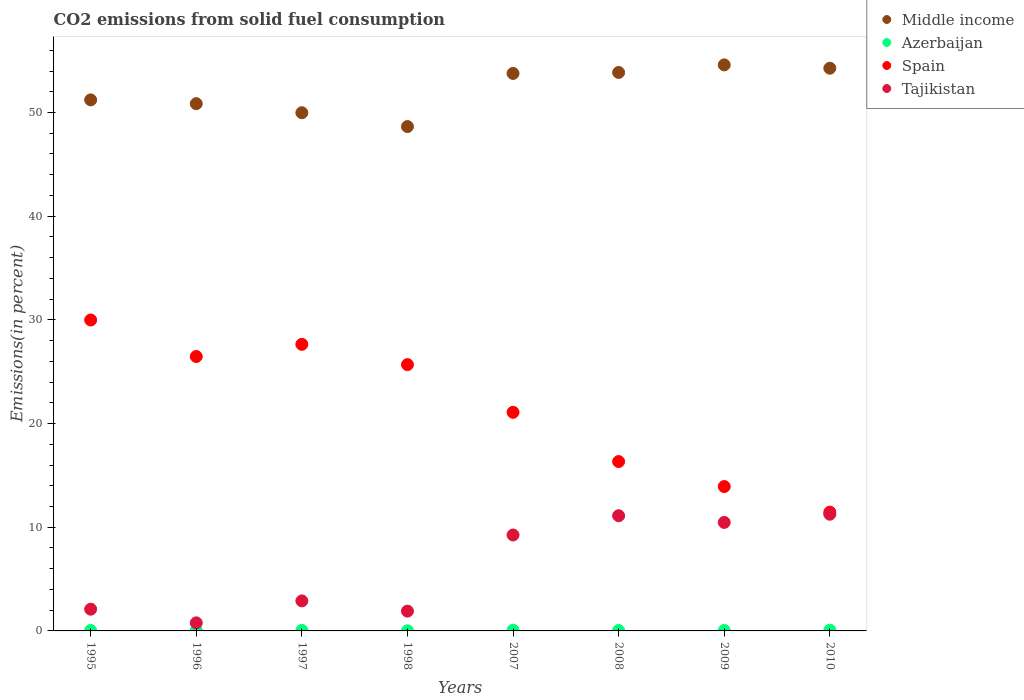How many different coloured dotlines are there?
Your answer should be very brief. 4. Is the number of dotlines equal to the number of legend labels?
Keep it short and to the point. Yes. What is the total CO2 emitted in Tajikistan in 1996?
Provide a short and direct response. 0.78. Across all years, what is the maximum total CO2 emitted in Tajikistan?
Offer a terse response. 11.25. Across all years, what is the minimum total CO2 emitted in Spain?
Offer a very short reply. 11.46. In which year was the total CO2 emitted in Middle income maximum?
Your answer should be very brief. 2009. In which year was the total CO2 emitted in Tajikistan minimum?
Keep it short and to the point. 1996. What is the total total CO2 emitted in Spain in the graph?
Offer a very short reply. 172.58. What is the difference between the total CO2 emitted in Spain in 1995 and that in 1998?
Offer a terse response. 4.3. What is the difference between the total CO2 emitted in Azerbaijan in 1997 and the total CO2 emitted in Tajikistan in 2010?
Your response must be concise. -11.21. What is the average total CO2 emitted in Spain per year?
Make the answer very short. 21.57. In the year 1996, what is the difference between the total CO2 emitted in Spain and total CO2 emitted in Middle income?
Your response must be concise. -24.39. In how many years, is the total CO2 emitted in Azerbaijan greater than 38 %?
Your answer should be compact. 0. What is the ratio of the total CO2 emitted in Azerbaijan in 1996 to that in 2008?
Provide a short and direct response. 1.13. Is the total CO2 emitted in Tajikistan in 1996 less than that in 1998?
Your answer should be very brief. Yes. What is the difference between the highest and the second highest total CO2 emitted in Tajikistan?
Offer a very short reply. 0.14. What is the difference between the highest and the lowest total CO2 emitted in Middle income?
Your response must be concise. 5.95. In how many years, is the total CO2 emitted in Azerbaijan greater than the average total CO2 emitted in Azerbaijan taken over all years?
Make the answer very short. 3. Is it the case that in every year, the sum of the total CO2 emitted in Azerbaijan and total CO2 emitted in Spain  is greater than the sum of total CO2 emitted in Tajikistan and total CO2 emitted in Middle income?
Give a very brief answer. No. Is it the case that in every year, the sum of the total CO2 emitted in Spain and total CO2 emitted in Azerbaijan  is greater than the total CO2 emitted in Tajikistan?
Offer a terse response. Yes. Is the total CO2 emitted in Azerbaijan strictly greater than the total CO2 emitted in Tajikistan over the years?
Give a very brief answer. No. Is the total CO2 emitted in Middle income strictly less than the total CO2 emitted in Spain over the years?
Your response must be concise. No. How many years are there in the graph?
Offer a terse response. 8. Are the values on the major ticks of Y-axis written in scientific E-notation?
Give a very brief answer. No. Does the graph contain any zero values?
Provide a short and direct response. No. How many legend labels are there?
Give a very brief answer. 4. What is the title of the graph?
Give a very brief answer. CO2 emissions from solid fuel consumption. Does "Oman" appear as one of the legend labels in the graph?
Give a very brief answer. No. What is the label or title of the Y-axis?
Your answer should be very brief. Emissions(in percent). What is the Emissions(in percent) in Middle income in 1995?
Ensure brevity in your answer.  51.22. What is the Emissions(in percent) of Azerbaijan in 1995?
Your answer should be very brief. 0.04. What is the Emissions(in percent) in Spain in 1995?
Offer a terse response. 29.99. What is the Emissions(in percent) in Tajikistan in 1995?
Offer a very short reply. 2.1. What is the Emissions(in percent) in Middle income in 1996?
Ensure brevity in your answer.  50.85. What is the Emissions(in percent) of Azerbaijan in 1996?
Your answer should be very brief. 0.05. What is the Emissions(in percent) in Spain in 1996?
Ensure brevity in your answer.  26.47. What is the Emissions(in percent) of Tajikistan in 1996?
Your response must be concise. 0.78. What is the Emissions(in percent) in Middle income in 1997?
Give a very brief answer. 49.98. What is the Emissions(in percent) in Azerbaijan in 1997?
Provide a short and direct response. 0.05. What is the Emissions(in percent) of Spain in 1997?
Your response must be concise. 27.64. What is the Emissions(in percent) of Tajikistan in 1997?
Offer a terse response. 2.9. What is the Emissions(in percent) in Middle income in 1998?
Provide a short and direct response. 48.64. What is the Emissions(in percent) in Azerbaijan in 1998?
Offer a very short reply. 0.01. What is the Emissions(in percent) in Spain in 1998?
Your response must be concise. 25.68. What is the Emissions(in percent) of Tajikistan in 1998?
Your answer should be compact. 1.91. What is the Emissions(in percent) in Middle income in 2007?
Your response must be concise. 53.77. What is the Emissions(in percent) of Azerbaijan in 2007?
Keep it short and to the point. 0.07. What is the Emissions(in percent) of Spain in 2007?
Offer a very short reply. 21.09. What is the Emissions(in percent) of Tajikistan in 2007?
Ensure brevity in your answer.  9.25. What is the Emissions(in percent) in Middle income in 2008?
Give a very brief answer. 53.86. What is the Emissions(in percent) in Azerbaijan in 2008?
Offer a very short reply. 0.04. What is the Emissions(in percent) of Spain in 2008?
Make the answer very short. 16.34. What is the Emissions(in percent) in Tajikistan in 2008?
Offer a terse response. 11.11. What is the Emissions(in percent) in Middle income in 2009?
Give a very brief answer. 54.6. What is the Emissions(in percent) in Azerbaijan in 2009?
Provide a succinct answer. 0.05. What is the Emissions(in percent) in Spain in 2009?
Keep it short and to the point. 13.92. What is the Emissions(in percent) in Tajikistan in 2009?
Provide a succinct answer. 10.47. What is the Emissions(in percent) of Middle income in 2010?
Provide a short and direct response. 54.27. What is the Emissions(in percent) of Azerbaijan in 2010?
Keep it short and to the point. 0.07. What is the Emissions(in percent) in Spain in 2010?
Your answer should be compact. 11.46. What is the Emissions(in percent) in Tajikistan in 2010?
Your answer should be compact. 11.25. Across all years, what is the maximum Emissions(in percent) of Middle income?
Offer a very short reply. 54.6. Across all years, what is the maximum Emissions(in percent) in Azerbaijan?
Keep it short and to the point. 0.07. Across all years, what is the maximum Emissions(in percent) in Spain?
Make the answer very short. 29.99. Across all years, what is the maximum Emissions(in percent) of Tajikistan?
Provide a short and direct response. 11.25. Across all years, what is the minimum Emissions(in percent) in Middle income?
Your response must be concise. 48.64. Across all years, what is the minimum Emissions(in percent) in Azerbaijan?
Give a very brief answer. 0.01. Across all years, what is the minimum Emissions(in percent) in Spain?
Offer a terse response. 11.46. Across all years, what is the minimum Emissions(in percent) of Tajikistan?
Your answer should be very brief. 0.78. What is the total Emissions(in percent) in Middle income in the graph?
Ensure brevity in your answer.  417.19. What is the total Emissions(in percent) in Azerbaijan in the graph?
Your answer should be compact. 0.38. What is the total Emissions(in percent) of Spain in the graph?
Your answer should be very brief. 172.58. What is the total Emissions(in percent) of Tajikistan in the graph?
Your response must be concise. 49.76. What is the difference between the Emissions(in percent) of Middle income in 1995 and that in 1996?
Make the answer very short. 0.36. What is the difference between the Emissions(in percent) of Azerbaijan in 1995 and that in 1996?
Ensure brevity in your answer.  -0. What is the difference between the Emissions(in percent) in Spain in 1995 and that in 1996?
Your response must be concise. 3.52. What is the difference between the Emissions(in percent) in Tajikistan in 1995 and that in 1996?
Your response must be concise. 1.32. What is the difference between the Emissions(in percent) of Middle income in 1995 and that in 1997?
Make the answer very short. 1.24. What is the difference between the Emissions(in percent) of Azerbaijan in 1995 and that in 1997?
Ensure brevity in your answer.  -0.01. What is the difference between the Emissions(in percent) of Spain in 1995 and that in 1997?
Offer a terse response. 2.35. What is the difference between the Emissions(in percent) in Tajikistan in 1995 and that in 1997?
Your answer should be very brief. -0.8. What is the difference between the Emissions(in percent) of Middle income in 1995 and that in 1998?
Your response must be concise. 2.57. What is the difference between the Emissions(in percent) of Azerbaijan in 1995 and that in 1998?
Offer a very short reply. 0.03. What is the difference between the Emissions(in percent) in Spain in 1995 and that in 1998?
Make the answer very short. 4.3. What is the difference between the Emissions(in percent) of Tajikistan in 1995 and that in 1998?
Give a very brief answer. 0.19. What is the difference between the Emissions(in percent) in Middle income in 1995 and that in 2007?
Provide a short and direct response. -2.55. What is the difference between the Emissions(in percent) in Azerbaijan in 1995 and that in 2007?
Offer a very short reply. -0.03. What is the difference between the Emissions(in percent) in Spain in 1995 and that in 2007?
Your response must be concise. 8.9. What is the difference between the Emissions(in percent) in Tajikistan in 1995 and that in 2007?
Keep it short and to the point. -7.16. What is the difference between the Emissions(in percent) in Middle income in 1995 and that in 2008?
Offer a very short reply. -2.65. What is the difference between the Emissions(in percent) of Azerbaijan in 1995 and that in 2008?
Provide a succinct answer. 0. What is the difference between the Emissions(in percent) in Spain in 1995 and that in 2008?
Your answer should be compact. 13.65. What is the difference between the Emissions(in percent) of Tajikistan in 1995 and that in 2008?
Ensure brevity in your answer.  -9.02. What is the difference between the Emissions(in percent) in Middle income in 1995 and that in 2009?
Ensure brevity in your answer.  -3.38. What is the difference between the Emissions(in percent) of Azerbaijan in 1995 and that in 2009?
Make the answer very short. -0. What is the difference between the Emissions(in percent) of Spain in 1995 and that in 2009?
Ensure brevity in your answer.  16.06. What is the difference between the Emissions(in percent) of Tajikistan in 1995 and that in 2009?
Keep it short and to the point. -8.37. What is the difference between the Emissions(in percent) of Middle income in 1995 and that in 2010?
Your answer should be compact. -3.05. What is the difference between the Emissions(in percent) in Azerbaijan in 1995 and that in 2010?
Provide a succinct answer. -0.03. What is the difference between the Emissions(in percent) of Spain in 1995 and that in 2010?
Make the answer very short. 18.53. What is the difference between the Emissions(in percent) of Tajikistan in 1995 and that in 2010?
Ensure brevity in your answer.  -9.16. What is the difference between the Emissions(in percent) in Middle income in 1996 and that in 1997?
Provide a succinct answer. 0.87. What is the difference between the Emissions(in percent) of Azerbaijan in 1996 and that in 1997?
Make the answer very short. -0. What is the difference between the Emissions(in percent) of Spain in 1996 and that in 1997?
Offer a very short reply. -1.17. What is the difference between the Emissions(in percent) in Tajikistan in 1996 and that in 1997?
Your response must be concise. -2.12. What is the difference between the Emissions(in percent) in Middle income in 1996 and that in 1998?
Make the answer very short. 2.21. What is the difference between the Emissions(in percent) of Azerbaijan in 1996 and that in 1998?
Your answer should be very brief. 0.04. What is the difference between the Emissions(in percent) in Spain in 1996 and that in 1998?
Provide a succinct answer. 0.78. What is the difference between the Emissions(in percent) of Tajikistan in 1996 and that in 1998?
Your response must be concise. -1.13. What is the difference between the Emissions(in percent) in Middle income in 1996 and that in 2007?
Offer a terse response. -2.92. What is the difference between the Emissions(in percent) of Azerbaijan in 1996 and that in 2007?
Your answer should be compact. -0.03. What is the difference between the Emissions(in percent) of Spain in 1996 and that in 2007?
Ensure brevity in your answer.  5.38. What is the difference between the Emissions(in percent) of Tajikistan in 1996 and that in 2007?
Provide a short and direct response. -8.47. What is the difference between the Emissions(in percent) of Middle income in 1996 and that in 2008?
Offer a very short reply. -3.01. What is the difference between the Emissions(in percent) in Azerbaijan in 1996 and that in 2008?
Provide a succinct answer. 0.01. What is the difference between the Emissions(in percent) of Spain in 1996 and that in 2008?
Give a very brief answer. 10.13. What is the difference between the Emissions(in percent) in Tajikistan in 1996 and that in 2008?
Your answer should be very brief. -10.33. What is the difference between the Emissions(in percent) of Middle income in 1996 and that in 2009?
Your response must be concise. -3.74. What is the difference between the Emissions(in percent) in Azerbaijan in 1996 and that in 2009?
Ensure brevity in your answer.  0. What is the difference between the Emissions(in percent) of Spain in 1996 and that in 2009?
Offer a very short reply. 12.54. What is the difference between the Emissions(in percent) of Tajikistan in 1996 and that in 2009?
Make the answer very short. -9.69. What is the difference between the Emissions(in percent) of Middle income in 1996 and that in 2010?
Keep it short and to the point. -3.42. What is the difference between the Emissions(in percent) of Azerbaijan in 1996 and that in 2010?
Your response must be concise. -0.03. What is the difference between the Emissions(in percent) in Spain in 1996 and that in 2010?
Your response must be concise. 15.01. What is the difference between the Emissions(in percent) of Tajikistan in 1996 and that in 2010?
Ensure brevity in your answer.  -10.48. What is the difference between the Emissions(in percent) of Middle income in 1997 and that in 1998?
Your answer should be very brief. 1.33. What is the difference between the Emissions(in percent) in Azerbaijan in 1997 and that in 1998?
Provide a short and direct response. 0.04. What is the difference between the Emissions(in percent) in Spain in 1997 and that in 1998?
Offer a very short reply. 1.96. What is the difference between the Emissions(in percent) in Tajikistan in 1997 and that in 1998?
Offer a terse response. 0.99. What is the difference between the Emissions(in percent) in Middle income in 1997 and that in 2007?
Provide a short and direct response. -3.79. What is the difference between the Emissions(in percent) of Azerbaijan in 1997 and that in 2007?
Your answer should be very brief. -0.02. What is the difference between the Emissions(in percent) of Spain in 1997 and that in 2007?
Ensure brevity in your answer.  6.56. What is the difference between the Emissions(in percent) in Tajikistan in 1997 and that in 2007?
Your answer should be very brief. -6.36. What is the difference between the Emissions(in percent) in Middle income in 1997 and that in 2008?
Provide a succinct answer. -3.88. What is the difference between the Emissions(in percent) of Azerbaijan in 1997 and that in 2008?
Your answer should be compact. 0.01. What is the difference between the Emissions(in percent) of Spain in 1997 and that in 2008?
Offer a very short reply. 11.31. What is the difference between the Emissions(in percent) in Tajikistan in 1997 and that in 2008?
Your answer should be compact. -8.21. What is the difference between the Emissions(in percent) of Middle income in 1997 and that in 2009?
Keep it short and to the point. -4.62. What is the difference between the Emissions(in percent) in Azerbaijan in 1997 and that in 2009?
Provide a short and direct response. 0. What is the difference between the Emissions(in percent) of Spain in 1997 and that in 2009?
Make the answer very short. 13.72. What is the difference between the Emissions(in percent) of Tajikistan in 1997 and that in 2009?
Your answer should be very brief. -7.57. What is the difference between the Emissions(in percent) of Middle income in 1997 and that in 2010?
Your answer should be compact. -4.29. What is the difference between the Emissions(in percent) of Azerbaijan in 1997 and that in 2010?
Provide a short and direct response. -0.02. What is the difference between the Emissions(in percent) of Spain in 1997 and that in 2010?
Your answer should be compact. 16.18. What is the difference between the Emissions(in percent) in Tajikistan in 1997 and that in 2010?
Provide a short and direct response. -8.36. What is the difference between the Emissions(in percent) in Middle income in 1998 and that in 2007?
Keep it short and to the point. -5.12. What is the difference between the Emissions(in percent) in Azerbaijan in 1998 and that in 2007?
Make the answer very short. -0.06. What is the difference between the Emissions(in percent) in Spain in 1998 and that in 2007?
Offer a terse response. 4.6. What is the difference between the Emissions(in percent) of Tajikistan in 1998 and that in 2007?
Your response must be concise. -7.34. What is the difference between the Emissions(in percent) in Middle income in 1998 and that in 2008?
Provide a succinct answer. -5.22. What is the difference between the Emissions(in percent) in Azerbaijan in 1998 and that in 2008?
Keep it short and to the point. -0.03. What is the difference between the Emissions(in percent) of Spain in 1998 and that in 2008?
Your response must be concise. 9.35. What is the difference between the Emissions(in percent) of Tajikistan in 1998 and that in 2008?
Give a very brief answer. -9.2. What is the difference between the Emissions(in percent) in Middle income in 1998 and that in 2009?
Ensure brevity in your answer.  -5.95. What is the difference between the Emissions(in percent) of Azerbaijan in 1998 and that in 2009?
Provide a succinct answer. -0.03. What is the difference between the Emissions(in percent) in Spain in 1998 and that in 2009?
Your answer should be very brief. 11.76. What is the difference between the Emissions(in percent) in Tajikistan in 1998 and that in 2009?
Keep it short and to the point. -8.56. What is the difference between the Emissions(in percent) in Middle income in 1998 and that in 2010?
Offer a very short reply. -5.63. What is the difference between the Emissions(in percent) in Azerbaijan in 1998 and that in 2010?
Offer a terse response. -0.06. What is the difference between the Emissions(in percent) of Spain in 1998 and that in 2010?
Give a very brief answer. 14.23. What is the difference between the Emissions(in percent) in Tajikistan in 1998 and that in 2010?
Keep it short and to the point. -9.35. What is the difference between the Emissions(in percent) in Middle income in 2007 and that in 2008?
Give a very brief answer. -0.09. What is the difference between the Emissions(in percent) of Azerbaijan in 2007 and that in 2008?
Your answer should be compact. 0.03. What is the difference between the Emissions(in percent) in Spain in 2007 and that in 2008?
Offer a terse response. 4.75. What is the difference between the Emissions(in percent) in Tajikistan in 2007 and that in 2008?
Offer a very short reply. -1.86. What is the difference between the Emissions(in percent) in Middle income in 2007 and that in 2009?
Offer a terse response. -0.83. What is the difference between the Emissions(in percent) of Azerbaijan in 2007 and that in 2009?
Make the answer very short. 0.03. What is the difference between the Emissions(in percent) in Spain in 2007 and that in 2009?
Make the answer very short. 7.16. What is the difference between the Emissions(in percent) of Tajikistan in 2007 and that in 2009?
Provide a short and direct response. -1.21. What is the difference between the Emissions(in percent) in Middle income in 2007 and that in 2010?
Provide a succinct answer. -0.5. What is the difference between the Emissions(in percent) of Spain in 2007 and that in 2010?
Offer a very short reply. 9.63. What is the difference between the Emissions(in percent) of Tajikistan in 2007 and that in 2010?
Provide a short and direct response. -2. What is the difference between the Emissions(in percent) in Middle income in 2008 and that in 2009?
Offer a terse response. -0.73. What is the difference between the Emissions(in percent) of Azerbaijan in 2008 and that in 2009?
Ensure brevity in your answer.  -0. What is the difference between the Emissions(in percent) in Spain in 2008 and that in 2009?
Provide a short and direct response. 2.41. What is the difference between the Emissions(in percent) in Tajikistan in 2008 and that in 2009?
Make the answer very short. 0.65. What is the difference between the Emissions(in percent) in Middle income in 2008 and that in 2010?
Keep it short and to the point. -0.41. What is the difference between the Emissions(in percent) in Azerbaijan in 2008 and that in 2010?
Give a very brief answer. -0.03. What is the difference between the Emissions(in percent) in Spain in 2008 and that in 2010?
Your answer should be very brief. 4.88. What is the difference between the Emissions(in percent) of Tajikistan in 2008 and that in 2010?
Ensure brevity in your answer.  -0.14. What is the difference between the Emissions(in percent) in Middle income in 2009 and that in 2010?
Make the answer very short. 0.32. What is the difference between the Emissions(in percent) of Azerbaijan in 2009 and that in 2010?
Ensure brevity in your answer.  -0.03. What is the difference between the Emissions(in percent) of Spain in 2009 and that in 2010?
Your response must be concise. 2.47. What is the difference between the Emissions(in percent) of Tajikistan in 2009 and that in 2010?
Provide a short and direct response. -0.79. What is the difference between the Emissions(in percent) in Middle income in 1995 and the Emissions(in percent) in Azerbaijan in 1996?
Make the answer very short. 51.17. What is the difference between the Emissions(in percent) of Middle income in 1995 and the Emissions(in percent) of Spain in 1996?
Your response must be concise. 24.75. What is the difference between the Emissions(in percent) in Middle income in 1995 and the Emissions(in percent) in Tajikistan in 1996?
Your answer should be compact. 50.44. What is the difference between the Emissions(in percent) in Azerbaijan in 1995 and the Emissions(in percent) in Spain in 1996?
Provide a short and direct response. -26.42. What is the difference between the Emissions(in percent) in Azerbaijan in 1995 and the Emissions(in percent) in Tajikistan in 1996?
Provide a short and direct response. -0.73. What is the difference between the Emissions(in percent) of Spain in 1995 and the Emissions(in percent) of Tajikistan in 1996?
Make the answer very short. 29.21. What is the difference between the Emissions(in percent) in Middle income in 1995 and the Emissions(in percent) in Azerbaijan in 1997?
Your answer should be compact. 51.17. What is the difference between the Emissions(in percent) in Middle income in 1995 and the Emissions(in percent) in Spain in 1997?
Give a very brief answer. 23.58. What is the difference between the Emissions(in percent) in Middle income in 1995 and the Emissions(in percent) in Tajikistan in 1997?
Your answer should be compact. 48.32. What is the difference between the Emissions(in percent) in Azerbaijan in 1995 and the Emissions(in percent) in Spain in 1997?
Make the answer very short. -27.6. What is the difference between the Emissions(in percent) of Azerbaijan in 1995 and the Emissions(in percent) of Tajikistan in 1997?
Provide a short and direct response. -2.85. What is the difference between the Emissions(in percent) of Spain in 1995 and the Emissions(in percent) of Tajikistan in 1997?
Your answer should be compact. 27.09. What is the difference between the Emissions(in percent) of Middle income in 1995 and the Emissions(in percent) of Azerbaijan in 1998?
Offer a terse response. 51.21. What is the difference between the Emissions(in percent) of Middle income in 1995 and the Emissions(in percent) of Spain in 1998?
Ensure brevity in your answer.  25.53. What is the difference between the Emissions(in percent) in Middle income in 1995 and the Emissions(in percent) in Tajikistan in 1998?
Ensure brevity in your answer.  49.31. What is the difference between the Emissions(in percent) in Azerbaijan in 1995 and the Emissions(in percent) in Spain in 1998?
Offer a very short reply. -25.64. What is the difference between the Emissions(in percent) of Azerbaijan in 1995 and the Emissions(in percent) of Tajikistan in 1998?
Your answer should be compact. -1.87. What is the difference between the Emissions(in percent) of Spain in 1995 and the Emissions(in percent) of Tajikistan in 1998?
Ensure brevity in your answer.  28.08. What is the difference between the Emissions(in percent) in Middle income in 1995 and the Emissions(in percent) in Azerbaijan in 2007?
Your response must be concise. 51.15. What is the difference between the Emissions(in percent) of Middle income in 1995 and the Emissions(in percent) of Spain in 2007?
Provide a short and direct response. 30.13. What is the difference between the Emissions(in percent) of Middle income in 1995 and the Emissions(in percent) of Tajikistan in 2007?
Your response must be concise. 41.96. What is the difference between the Emissions(in percent) in Azerbaijan in 1995 and the Emissions(in percent) in Spain in 2007?
Your answer should be very brief. -21.04. What is the difference between the Emissions(in percent) in Azerbaijan in 1995 and the Emissions(in percent) in Tajikistan in 2007?
Your response must be concise. -9.21. What is the difference between the Emissions(in percent) of Spain in 1995 and the Emissions(in percent) of Tajikistan in 2007?
Provide a short and direct response. 20.74. What is the difference between the Emissions(in percent) in Middle income in 1995 and the Emissions(in percent) in Azerbaijan in 2008?
Offer a terse response. 51.18. What is the difference between the Emissions(in percent) in Middle income in 1995 and the Emissions(in percent) in Spain in 2008?
Offer a terse response. 34.88. What is the difference between the Emissions(in percent) of Middle income in 1995 and the Emissions(in percent) of Tajikistan in 2008?
Make the answer very short. 40.11. What is the difference between the Emissions(in percent) of Azerbaijan in 1995 and the Emissions(in percent) of Spain in 2008?
Give a very brief answer. -16.29. What is the difference between the Emissions(in percent) in Azerbaijan in 1995 and the Emissions(in percent) in Tajikistan in 2008?
Make the answer very short. -11.07. What is the difference between the Emissions(in percent) in Spain in 1995 and the Emissions(in percent) in Tajikistan in 2008?
Ensure brevity in your answer.  18.88. What is the difference between the Emissions(in percent) of Middle income in 1995 and the Emissions(in percent) of Azerbaijan in 2009?
Ensure brevity in your answer.  51.17. What is the difference between the Emissions(in percent) in Middle income in 1995 and the Emissions(in percent) in Spain in 2009?
Provide a succinct answer. 37.29. What is the difference between the Emissions(in percent) in Middle income in 1995 and the Emissions(in percent) in Tajikistan in 2009?
Your answer should be very brief. 40.75. What is the difference between the Emissions(in percent) of Azerbaijan in 1995 and the Emissions(in percent) of Spain in 2009?
Provide a succinct answer. -13.88. What is the difference between the Emissions(in percent) in Azerbaijan in 1995 and the Emissions(in percent) in Tajikistan in 2009?
Provide a succinct answer. -10.42. What is the difference between the Emissions(in percent) of Spain in 1995 and the Emissions(in percent) of Tajikistan in 2009?
Your answer should be compact. 19.52. What is the difference between the Emissions(in percent) in Middle income in 1995 and the Emissions(in percent) in Azerbaijan in 2010?
Offer a very short reply. 51.15. What is the difference between the Emissions(in percent) of Middle income in 1995 and the Emissions(in percent) of Spain in 2010?
Your response must be concise. 39.76. What is the difference between the Emissions(in percent) of Middle income in 1995 and the Emissions(in percent) of Tajikistan in 2010?
Offer a very short reply. 39.96. What is the difference between the Emissions(in percent) in Azerbaijan in 1995 and the Emissions(in percent) in Spain in 2010?
Offer a very short reply. -11.41. What is the difference between the Emissions(in percent) in Azerbaijan in 1995 and the Emissions(in percent) in Tajikistan in 2010?
Make the answer very short. -11.21. What is the difference between the Emissions(in percent) of Spain in 1995 and the Emissions(in percent) of Tajikistan in 2010?
Your response must be concise. 18.73. What is the difference between the Emissions(in percent) of Middle income in 1996 and the Emissions(in percent) of Azerbaijan in 1997?
Make the answer very short. 50.8. What is the difference between the Emissions(in percent) of Middle income in 1996 and the Emissions(in percent) of Spain in 1997?
Provide a short and direct response. 23.21. What is the difference between the Emissions(in percent) of Middle income in 1996 and the Emissions(in percent) of Tajikistan in 1997?
Offer a very short reply. 47.96. What is the difference between the Emissions(in percent) of Azerbaijan in 1996 and the Emissions(in percent) of Spain in 1997?
Your response must be concise. -27.59. What is the difference between the Emissions(in percent) of Azerbaijan in 1996 and the Emissions(in percent) of Tajikistan in 1997?
Offer a terse response. -2.85. What is the difference between the Emissions(in percent) in Spain in 1996 and the Emissions(in percent) in Tajikistan in 1997?
Provide a short and direct response. 23.57. What is the difference between the Emissions(in percent) in Middle income in 1996 and the Emissions(in percent) in Azerbaijan in 1998?
Offer a very short reply. 50.84. What is the difference between the Emissions(in percent) of Middle income in 1996 and the Emissions(in percent) of Spain in 1998?
Ensure brevity in your answer.  25.17. What is the difference between the Emissions(in percent) in Middle income in 1996 and the Emissions(in percent) in Tajikistan in 1998?
Keep it short and to the point. 48.94. What is the difference between the Emissions(in percent) of Azerbaijan in 1996 and the Emissions(in percent) of Spain in 1998?
Offer a very short reply. -25.64. What is the difference between the Emissions(in percent) of Azerbaijan in 1996 and the Emissions(in percent) of Tajikistan in 1998?
Offer a very short reply. -1.86. What is the difference between the Emissions(in percent) of Spain in 1996 and the Emissions(in percent) of Tajikistan in 1998?
Your answer should be very brief. 24.56. What is the difference between the Emissions(in percent) in Middle income in 1996 and the Emissions(in percent) in Azerbaijan in 2007?
Give a very brief answer. 50.78. What is the difference between the Emissions(in percent) in Middle income in 1996 and the Emissions(in percent) in Spain in 2007?
Keep it short and to the point. 29.77. What is the difference between the Emissions(in percent) in Middle income in 1996 and the Emissions(in percent) in Tajikistan in 2007?
Offer a terse response. 41.6. What is the difference between the Emissions(in percent) in Azerbaijan in 1996 and the Emissions(in percent) in Spain in 2007?
Provide a succinct answer. -21.04. What is the difference between the Emissions(in percent) of Azerbaijan in 1996 and the Emissions(in percent) of Tajikistan in 2007?
Provide a short and direct response. -9.21. What is the difference between the Emissions(in percent) of Spain in 1996 and the Emissions(in percent) of Tajikistan in 2007?
Provide a short and direct response. 17.21. What is the difference between the Emissions(in percent) in Middle income in 1996 and the Emissions(in percent) in Azerbaijan in 2008?
Keep it short and to the point. 50.81. What is the difference between the Emissions(in percent) of Middle income in 1996 and the Emissions(in percent) of Spain in 2008?
Ensure brevity in your answer.  34.52. What is the difference between the Emissions(in percent) in Middle income in 1996 and the Emissions(in percent) in Tajikistan in 2008?
Your response must be concise. 39.74. What is the difference between the Emissions(in percent) of Azerbaijan in 1996 and the Emissions(in percent) of Spain in 2008?
Provide a short and direct response. -16.29. What is the difference between the Emissions(in percent) of Azerbaijan in 1996 and the Emissions(in percent) of Tajikistan in 2008?
Offer a terse response. -11.06. What is the difference between the Emissions(in percent) in Spain in 1996 and the Emissions(in percent) in Tajikistan in 2008?
Your answer should be compact. 15.36. What is the difference between the Emissions(in percent) of Middle income in 1996 and the Emissions(in percent) of Azerbaijan in 2009?
Your answer should be very brief. 50.81. What is the difference between the Emissions(in percent) of Middle income in 1996 and the Emissions(in percent) of Spain in 2009?
Offer a very short reply. 36.93. What is the difference between the Emissions(in percent) in Middle income in 1996 and the Emissions(in percent) in Tajikistan in 2009?
Offer a very short reply. 40.39. What is the difference between the Emissions(in percent) in Azerbaijan in 1996 and the Emissions(in percent) in Spain in 2009?
Offer a terse response. -13.88. What is the difference between the Emissions(in percent) of Azerbaijan in 1996 and the Emissions(in percent) of Tajikistan in 2009?
Your response must be concise. -10.42. What is the difference between the Emissions(in percent) of Spain in 1996 and the Emissions(in percent) of Tajikistan in 2009?
Keep it short and to the point. 16. What is the difference between the Emissions(in percent) of Middle income in 1996 and the Emissions(in percent) of Azerbaijan in 2010?
Keep it short and to the point. 50.78. What is the difference between the Emissions(in percent) in Middle income in 1996 and the Emissions(in percent) in Spain in 2010?
Your answer should be very brief. 39.4. What is the difference between the Emissions(in percent) in Middle income in 1996 and the Emissions(in percent) in Tajikistan in 2010?
Offer a very short reply. 39.6. What is the difference between the Emissions(in percent) of Azerbaijan in 1996 and the Emissions(in percent) of Spain in 2010?
Provide a succinct answer. -11.41. What is the difference between the Emissions(in percent) of Azerbaijan in 1996 and the Emissions(in percent) of Tajikistan in 2010?
Your response must be concise. -11.21. What is the difference between the Emissions(in percent) in Spain in 1996 and the Emissions(in percent) in Tajikistan in 2010?
Give a very brief answer. 15.21. What is the difference between the Emissions(in percent) in Middle income in 1997 and the Emissions(in percent) in Azerbaijan in 1998?
Your response must be concise. 49.97. What is the difference between the Emissions(in percent) in Middle income in 1997 and the Emissions(in percent) in Spain in 1998?
Your answer should be very brief. 24.29. What is the difference between the Emissions(in percent) in Middle income in 1997 and the Emissions(in percent) in Tajikistan in 1998?
Offer a very short reply. 48.07. What is the difference between the Emissions(in percent) of Azerbaijan in 1997 and the Emissions(in percent) of Spain in 1998?
Your answer should be compact. -25.64. What is the difference between the Emissions(in percent) of Azerbaijan in 1997 and the Emissions(in percent) of Tajikistan in 1998?
Keep it short and to the point. -1.86. What is the difference between the Emissions(in percent) in Spain in 1997 and the Emissions(in percent) in Tajikistan in 1998?
Your answer should be compact. 25.73. What is the difference between the Emissions(in percent) of Middle income in 1997 and the Emissions(in percent) of Azerbaijan in 2007?
Offer a very short reply. 49.91. What is the difference between the Emissions(in percent) in Middle income in 1997 and the Emissions(in percent) in Spain in 2007?
Provide a short and direct response. 28.89. What is the difference between the Emissions(in percent) in Middle income in 1997 and the Emissions(in percent) in Tajikistan in 2007?
Your answer should be compact. 40.73. What is the difference between the Emissions(in percent) of Azerbaijan in 1997 and the Emissions(in percent) of Spain in 2007?
Give a very brief answer. -21.04. What is the difference between the Emissions(in percent) of Azerbaijan in 1997 and the Emissions(in percent) of Tajikistan in 2007?
Make the answer very short. -9.2. What is the difference between the Emissions(in percent) in Spain in 1997 and the Emissions(in percent) in Tajikistan in 2007?
Your answer should be compact. 18.39. What is the difference between the Emissions(in percent) in Middle income in 1997 and the Emissions(in percent) in Azerbaijan in 2008?
Offer a very short reply. 49.94. What is the difference between the Emissions(in percent) of Middle income in 1997 and the Emissions(in percent) of Spain in 2008?
Keep it short and to the point. 33.64. What is the difference between the Emissions(in percent) of Middle income in 1997 and the Emissions(in percent) of Tajikistan in 2008?
Provide a short and direct response. 38.87. What is the difference between the Emissions(in percent) of Azerbaijan in 1997 and the Emissions(in percent) of Spain in 2008?
Offer a terse response. -16.29. What is the difference between the Emissions(in percent) of Azerbaijan in 1997 and the Emissions(in percent) of Tajikistan in 2008?
Your answer should be very brief. -11.06. What is the difference between the Emissions(in percent) of Spain in 1997 and the Emissions(in percent) of Tajikistan in 2008?
Your answer should be compact. 16.53. What is the difference between the Emissions(in percent) in Middle income in 1997 and the Emissions(in percent) in Azerbaijan in 2009?
Your answer should be very brief. 49.93. What is the difference between the Emissions(in percent) in Middle income in 1997 and the Emissions(in percent) in Spain in 2009?
Give a very brief answer. 36.05. What is the difference between the Emissions(in percent) in Middle income in 1997 and the Emissions(in percent) in Tajikistan in 2009?
Your response must be concise. 39.51. What is the difference between the Emissions(in percent) in Azerbaijan in 1997 and the Emissions(in percent) in Spain in 2009?
Provide a succinct answer. -13.88. What is the difference between the Emissions(in percent) in Azerbaijan in 1997 and the Emissions(in percent) in Tajikistan in 2009?
Provide a succinct answer. -10.42. What is the difference between the Emissions(in percent) in Spain in 1997 and the Emissions(in percent) in Tajikistan in 2009?
Make the answer very short. 17.18. What is the difference between the Emissions(in percent) of Middle income in 1997 and the Emissions(in percent) of Azerbaijan in 2010?
Provide a succinct answer. 49.91. What is the difference between the Emissions(in percent) of Middle income in 1997 and the Emissions(in percent) of Spain in 2010?
Your answer should be very brief. 38.52. What is the difference between the Emissions(in percent) of Middle income in 1997 and the Emissions(in percent) of Tajikistan in 2010?
Keep it short and to the point. 38.72. What is the difference between the Emissions(in percent) of Azerbaijan in 1997 and the Emissions(in percent) of Spain in 2010?
Provide a succinct answer. -11.41. What is the difference between the Emissions(in percent) in Azerbaijan in 1997 and the Emissions(in percent) in Tajikistan in 2010?
Offer a terse response. -11.21. What is the difference between the Emissions(in percent) of Spain in 1997 and the Emissions(in percent) of Tajikistan in 2010?
Offer a terse response. 16.39. What is the difference between the Emissions(in percent) in Middle income in 1998 and the Emissions(in percent) in Azerbaijan in 2007?
Your answer should be compact. 48.57. What is the difference between the Emissions(in percent) in Middle income in 1998 and the Emissions(in percent) in Spain in 2007?
Keep it short and to the point. 27.56. What is the difference between the Emissions(in percent) in Middle income in 1998 and the Emissions(in percent) in Tajikistan in 2007?
Offer a very short reply. 39.39. What is the difference between the Emissions(in percent) of Azerbaijan in 1998 and the Emissions(in percent) of Spain in 2007?
Ensure brevity in your answer.  -21.07. What is the difference between the Emissions(in percent) of Azerbaijan in 1998 and the Emissions(in percent) of Tajikistan in 2007?
Provide a succinct answer. -9.24. What is the difference between the Emissions(in percent) in Spain in 1998 and the Emissions(in percent) in Tajikistan in 2007?
Your answer should be compact. 16.43. What is the difference between the Emissions(in percent) of Middle income in 1998 and the Emissions(in percent) of Azerbaijan in 2008?
Your answer should be very brief. 48.6. What is the difference between the Emissions(in percent) in Middle income in 1998 and the Emissions(in percent) in Spain in 2008?
Provide a succinct answer. 32.31. What is the difference between the Emissions(in percent) of Middle income in 1998 and the Emissions(in percent) of Tajikistan in 2008?
Offer a very short reply. 37.53. What is the difference between the Emissions(in percent) of Azerbaijan in 1998 and the Emissions(in percent) of Spain in 2008?
Give a very brief answer. -16.32. What is the difference between the Emissions(in percent) of Azerbaijan in 1998 and the Emissions(in percent) of Tajikistan in 2008?
Your response must be concise. -11.1. What is the difference between the Emissions(in percent) in Spain in 1998 and the Emissions(in percent) in Tajikistan in 2008?
Offer a terse response. 14.57. What is the difference between the Emissions(in percent) in Middle income in 1998 and the Emissions(in percent) in Azerbaijan in 2009?
Offer a very short reply. 48.6. What is the difference between the Emissions(in percent) of Middle income in 1998 and the Emissions(in percent) of Spain in 2009?
Make the answer very short. 34.72. What is the difference between the Emissions(in percent) of Middle income in 1998 and the Emissions(in percent) of Tajikistan in 2009?
Make the answer very short. 38.18. What is the difference between the Emissions(in percent) in Azerbaijan in 1998 and the Emissions(in percent) in Spain in 2009?
Your response must be concise. -13.91. What is the difference between the Emissions(in percent) in Azerbaijan in 1998 and the Emissions(in percent) in Tajikistan in 2009?
Your response must be concise. -10.45. What is the difference between the Emissions(in percent) of Spain in 1998 and the Emissions(in percent) of Tajikistan in 2009?
Give a very brief answer. 15.22. What is the difference between the Emissions(in percent) of Middle income in 1998 and the Emissions(in percent) of Azerbaijan in 2010?
Your answer should be compact. 48.57. What is the difference between the Emissions(in percent) of Middle income in 1998 and the Emissions(in percent) of Spain in 2010?
Ensure brevity in your answer.  37.19. What is the difference between the Emissions(in percent) in Middle income in 1998 and the Emissions(in percent) in Tajikistan in 2010?
Your answer should be compact. 37.39. What is the difference between the Emissions(in percent) in Azerbaijan in 1998 and the Emissions(in percent) in Spain in 2010?
Provide a succinct answer. -11.45. What is the difference between the Emissions(in percent) in Azerbaijan in 1998 and the Emissions(in percent) in Tajikistan in 2010?
Offer a very short reply. -11.24. What is the difference between the Emissions(in percent) of Spain in 1998 and the Emissions(in percent) of Tajikistan in 2010?
Provide a short and direct response. 14.43. What is the difference between the Emissions(in percent) in Middle income in 2007 and the Emissions(in percent) in Azerbaijan in 2008?
Keep it short and to the point. 53.73. What is the difference between the Emissions(in percent) of Middle income in 2007 and the Emissions(in percent) of Spain in 2008?
Offer a terse response. 37.43. What is the difference between the Emissions(in percent) of Middle income in 2007 and the Emissions(in percent) of Tajikistan in 2008?
Offer a terse response. 42.66. What is the difference between the Emissions(in percent) in Azerbaijan in 2007 and the Emissions(in percent) in Spain in 2008?
Provide a succinct answer. -16.26. What is the difference between the Emissions(in percent) of Azerbaijan in 2007 and the Emissions(in percent) of Tajikistan in 2008?
Give a very brief answer. -11.04. What is the difference between the Emissions(in percent) in Spain in 2007 and the Emissions(in percent) in Tajikistan in 2008?
Provide a succinct answer. 9.97. What is the difference between the Emissions(in percent) of Middle income in 2007 and the Emissions(in percent) of Azerbaijan in 2009?
Make the answer very short. 53.72. What is the difference between the Emissions(in percent) of Middle income in 2007 and the Emissions(in percent) of Spain in 2009?
Your answer should be compact. 39.84. What is the difference between the Emissions(in percent) of Middle income in 2007 and the Emissions(in percent) of Tajikistan in 2009?
Your response must be concise. 43.3. What is the difference between the Emissions(in percent) in Azerbaijan in 2007 and the Emissions(in percent) in Spain in 2009?
Provide a short and direct response. -13.85. What is the difference between the Emissions(in percent) of Azerbaijan in 2007 and the Emissions(in percent) of Tajikistan in 2009?
Keep it short and to the point. -10.39. What is the difference between the Emissions(in percent) in Spain in 2007 and the Emissions(in percent) in Tajikistan in 2009?
Your answer should be very brief. 10.62. What is the difference between the Emissions(in percent) in Middle income in 2007 and the Emissions(in percent) in Azerbaijan in 2010?
Make the answer very short. 53.7. What is the difference between the Emissions(in percent) of Middle income in 2007 and the Emissions(in percent) of Spain in 2010?
Your answer should be very brief. 42.31. What is the difference between the Emissions(in percent) of Middle income in 2007 and the Emissions(in percent) of Tajikistan in 2010?
Give a very brief answer. 42.51. What is the difference between the Emissions(in percent) of Azerbaijan in 2007 and the Emissions(in percent) of Spain in 2010?
Ensure brevity in your answer.  -11.38. What is the difference between the Emissions(in percent) of Azerbaijan in 2007 and the Emissions(in percent) of Tajikistan in 2010?
Your answer should be very brief. -11.18. What is the difference between the Emissions(in percent) of Spain in 2007 and the Emissions(in percent) of Tajikistan in 2010?
Your answer should be compact. 9.83. What is the difference between the Emissions(in percent) of Middle income in 2008 and the Emissions(in percent) of Azerbaijan in 2009?
Your answer should be very brief. 53.82. What is the difference between the Emissions(in percent) in Middle income in 2008 and the Emissions(in percent) in Spain in 2009?
Ensure brevity in your answer.  39.94. What is the difference between the Emissions(in percent) of Middle income in 2008 and the Emissions(in percent) of Tajikistan in 2009?
Make the answer very short. 43.4. What is the difference between the Emissions(in percent) of Azerbaijan in 2008 and the Emissions(in percent) of Spain in 2009?
Provide a succinct answer. -13.88. What is the difference between the Emissions(in percent) of Azerbaijan in 2008 and the Emissions(in percent) of Tajikistan in 2009?
Make the answer very short. -10.42. What is the difference between the Emissions(in percent) of Spain in 2008 and the Emissions(in percent) of Tajikistan in 2009?
Make the answer very short. 5.87. What is the difference between the Emissions(in percent) in Middle income in 2008 and the Emissions(in percent) in Azerbaijan in 2010?
Your response must be concise. 53.79. What is the difference between the Emissions(in percent) in Middle income in 2008 and the Emissions(in percent) in Spain in 2010?
Keep it short and to the point. 42.41. What is the difference between the Emissions(in percent) of Middle income in 2008 and the Emissions(in percent) of Tajikistan in 2010?
Provide a succinct answer. 42.61. What is the difference between the Emissions(in percent) in Azerbaijan in 2008 and the Emissions(in percent) in Spain in 2010?
Offer a terse response. -11.42. What is the difference between the Emissions(in percent) in Azerbaijan in 2008 and the Emissions(in percent) in Tajikistan in 2010?
Your response must be concise. -11.21. What is the difference between the Emissions(in percent) of Spain in 2008 and the Emissions(in percent) of Tajikistan in 2010?
Make the answer very short. 5.08. What is the difference between the Emissions(in percent) in Middle income in 2009 and the Emissions(in percent) in Azerbaijan in 2010?
Ensure brevity in your answer.  54.52. What is the difference between the Emissions(in percent) of Middle income in 2009 and the Emissions(in percent) of Spain in 2010?
Your answer should be compact. 43.14. What is the difference between the Emissions(in percent) of Middle income in 2009 and the Emissions(in percent) of Tajikistan in 2010?
Your answer should be very brief. 43.34. What is the difference between the Emissions(in percent) in Azerbaijan in 2009 and the Emissions(in percent) in Spain in 2010?
Your response must be concise. -11.41. What is the difference between the Emissions(in percent) in Azerbaijan in 2009 and the Emissions(in percent) in Tajikistan in 2010?
Provide a succinct answer. -11.21. What is the difference between the Emissions(in percent) in Spain in 2009 and the Emissions(in percent) in Tajikistan in 2010?
Your answer should be very brief. 2.67. What is the average Emissions(in percent) in Middle income per year?
Provide a succinct answer. 52.15. What is the average Emissions(in percent) in Azerbaijan per year?
Your response must be concise. 0.05. What is the average Emissions(in percent) of Spain per year?
Provide a succinct answer. 21.57. What is the average Emissions(in percent) in Tajikistan per year?
Provide a succinct answer. 6.22. In the year 1995, what is the difference between the Emissions(in percent) in Middle income and Emissions(in percent) in Azerbaijan?
Ensure brevity in your answer.  51.17. In the year 1995, what is the difference between the Emissions(in percent) in Middle income and Emissions(in percent) in Spain?
Offer a terse response. 21.23. In the year 1995, what is the difference between the Emissions(in percent) in Middle income and Emissions(in percent) in Tajikistan?
Provide a short and direct response. 49.12. In the year 1995, what is the difference between the Emissions(in percent) of Azerbaijan and Emissions(in percent) of Spain?
Make the answer very short. -29.95. In the year 1995, what is the difference between the Emissions(in percent) of Azerbaijan and Emissions(in percent) of Tajikistan?
Keep it short and to the point. -2.05. In the year 1995, what is the difference between the Emissions(in percent) of Spain and Emissions(in percent) of Tajikistan?
Your answer should be very brief. 27.89. In the year 1996, what is the difference between the Emissions(in percent) in Middle income and Emissions(in percent) in Azerbaijan?
Offer a very short reply. 50.81. In the year 1996, what is the difference between the Emissions(in percent) of Middle income and Emissions(in percent) of Spain?
Give a very brief answer. 24.39. In the year 1996, what is the difference between the Emissions(in percent) in Middle income and Emissions(in percent) in Tajikistan?
Provide a short and direct response. 50.07. In the year 1996, what is the difference between the Emissions(in percent) in Azerbaijan and Emissions(in percent) in Spain?
Your answer should be compact. -26.42. In the year 1996, what is the difference between the Emissions(in percent) in Azerbaijan and Emissions(in percent) in Tajikistan?
Ensure brevity in your answer.  -0.73. In the year 1996, what is the difference between the Emissions(in percent) in Spain and Emissions(in percent) in Tajikistan?
Your answer should be compact. 25.69. In the year 1997, what is the difference between the Emissions(in percent) in Middle income and Emissions(in percent) in Azerbaijan?
Offer a terse response. 49.93. In the year 1997, what is the difference between the Emissions(in percent) in Middle income and Emissions(in percent) in Spain?
Your answer should be compact. 22.34. In the year 1997, what is the difference between the Emissions(in percent) in Middle income and Emissions(in percent) in Tajikistan?
Give a very brief answer. 47.08. In the year 1997, what is the difference between the Emissions(in percent) in Azerbaijan and Emissions(in percent) in Spain?
Your answer should be compact. -27.59. In the year 1997, what is the difference between the Emissions(in percent) in Azerbaijan and Emissions(in percent) in Tajikistan?
Make the answer very short. -2.85. In the year 1997, what is the difference between the Emissions(in percent) of Spain and Emissions(in percent) of Tajikistan?
Offer a terse response. 24.75. In the year 1998, what is the difference between the Emissions(in percent) in Middle income and Emissions(in percent) in Azerbaijan?
Offer a terse response. 48.63. In the year 1998, what is the difference between the Emissions(in percent) in Middle income and Emissions(in percent) in Spain?
Offer a very short reply. 22.96. In the year 1998, what is the difference between the Emissions(in percent) in Middle income and Emissions(in percent) in Tajikistan?
Make the answer very short. 46.74. In the year 1998, what is the difference between the Emissions(in percent) in Azerbaijan and Emissions(in percent) in Spain?
Your response must be concise. -25.67. In the year 1998, what is the difference between the Emissions(in percent) in Azerbaijan and Emissions(in percent) in Tajikistan?
Ensure brevity in your answer.  -1.9. In the year 1998, what is the difference between the Emissions(in percent) in Spain and Emissions(in percent) in Tajikistan?
Your response must be concise. 23.78. In the year 2007, what is the difference between the Emissions(in percent) in Middle income and Emissions(in percent) in Azerbaijan?
Keep it short and to the point. 53.7. In the year 2007, what is the difference between the Emissions(in percent) in Middle income and Emissions(in percent) in Spain?
Make the answer very short. 32.68. In the year 2007, what is the difference between the Emissions(in percent) of Middle income and Emissions(in percent) of Tajikistan?
Provide a short and direct response. 44.52. In the year 2007, what is the difference between the Emissions(in percent) in Azerbaijan and Emissions(in percent) in Spain?
Offer a very short reply. -21.01. In the year 2007, what is the difference between the Emissions(in percent) in Azerbaijan and Emissions(in percent) in Tajikistan?
Ensure brevity in your answer.  -9.18. In the year 2007, what is the difference between the Emissions(in percent) of Spain and Emissions(in percent) of Tajikistan?
Provide a succinct answer. 11.83. In the year 2008, what is the difference between the Emissions(in percent) in Middle income and Emissions(in percent) in Azerbaijan?
Your answer should be compact. 53.82. In the year 2008, what is the difference between the Emissions(in percent) in Middle income and Emissions(in percent) in Spain?
Your answer should be very brief. 37.53. In the year 2008, what is the difference between the Emissions(in percent) in Middle income and Emissions(in percent) in Tajikistan?
Ensure brevity in your answer.  42.75. In the year 2008, what is the difference between the Emissions(in percent) of Azerbaijan and Emissions(in percent) of Spain?
Offer a terse response. -16.29. In the year 2008, what is the difference between the Emissions(in percent) of Azerbaijan and Emissions(in percent) of Tajikistan?
Your answer should be very brief. -11.07. In the year 2008, what is the difference between the Emissions(in percent) in Spain and Emissions(in percent) in Tajikistan?
Ensure brevity in your answer.  5.22. In the year 2009, what is the difference between the Emissions(in percent) of Middle income and Emissions(in percent) of Azerbaijan?
Provide a short and direct response. 54.55. In the year 2009, what is the difference between the Emissions(in percent) in Middle income and Emissions(in percent) in Spain?
Ensure brevity in your answer.  40.67. In the year 2009, what is the difference between the Emissions(in percent) of Middle income and Emissions(in percent) of Tajikistan?
Provide a short and direct response. 44.13. In the year 2009, what is the difference between the Emissions(in percent) in Azerbaijan and Emissions(in percent) in Spain?
Provide a succinct answer. -13.88. In the year 2009, what is the difference between the Emissions(in percent) in Azerbaijan and Emissions(in percent) in Tajikistan?
Provide a succinct answer. -10.42. In the year 2009, what is the difference between the Emissions(in percent) of Spain and Emissions(in percent) of Tajikistan?
Your answer should be compact. 3.46. In the year 2010, what is the difference between the Emissions(in percent) of Middle income and Emissions(in percent) of Azerbaijan?
Your answer should be very brief. 54.2. In the year 2010, what is the difference between the Emissions(in percent) of Middle income and Emissions(in percent) of Spain?
Keep it short and to the point. 42.82. In the year 2010, what is the difference between the Emissions(in percent) of Middle income and Emissions(in percent) of Tajikistan?
Make the answer very short. 43.02. In the year 2010, what is the difference between the Emissions(in percent) of Azerbaijan and Emissions(in percent) of Spain?
Your response must be concise. -11.38. In the year 2010, what is the difference between the Emissions(in percent) of Azerbaijan and Emissions(in percent) of Tajikistan?
Your answer should be compact. -11.18. In the year 2010, what is the difference between the Emissions(in percent) in Spain and Emissions(in percent) in Tajikistan?
Your answer should be compact. 0.2. What is the ratio of the Emissions(in percent) of Azerbaijan in 1995 to that in 1996?
Make the answer very short. 0.94. What is the ratio of the Emissions(in percent) of Spain in 1995 to that in 1996?
Keep it short and to the point. 1.13. What is the ratio of the Emissions(in percent) of Tajikistan in 1995 to that in 1996?
Provide a succinct answer. 2.69. What is the ratio of the Emissions(in percent) of Middle income in 1995 to that in 1997?
Your answer should be compact. 1.02. What is the ratio of the Emissions(in percent) in Azerbaijan in 1995 to that in 1997?
Make the answer very short. 0.89. What is the ratio of the Emissions(in percent) in Spain in 1995 to that in 1997?
Provide a short and direct response. 1.08. What is the ratio of the Emissions(in percent) in Tajikistan in 1995 to that in 1997?
Ensure brevity in your answer.  0.72. What is the ratio of the Emissions(in percent) in Middle income in 1995 to that in 1998?
Offer a terse response. 1.05. What is the ratio of the Emissions(in percent) in Azerbaijan in 1995 to that in 1998?
Provide a short and direct response. 3.78. What is the ratio of the Emissions(in percent) in Spain in 1995 to that in 1998?
Give a very brief answer. 1.17. What is the ratio of the Emissions(in percent) in Tajikistan in 1995 to that in 1998?
Ensure brevity in your answer.  1.1. What is the ratio of the Emissions(in percent) in Middle income in 1995 to that in 2007?
Give a very brief answer. 0.95. What is the ratio of the Emissions(in percent) of Azerbaijan in 1995 to that in 2007?
Ensure brevity in your answer.  0.61. What is the ratio of the Emissions(in percent) in Spain in 1995 to that in 2007?
Provide a succinct answer. 1.42. What is the ratio of the Emissions(in percent) of Tajikistan in 1995 to that in 2007?
Provide a succinct answer. 0.23. What is the ratio of the Emissions(in percent) of Middle income in 1995 to that in 2008?
Give a very brief answer. 0.95. What is the ratio of the Emissions(in percent) in Azerbaijan in 1995 to that in 2008?
Your response must be concise. 1.06. What is the ratio of the Emissions(in percent) in Spain in 1995 to that in 2008?
Make the answer very short. 1.84. What is the ratio of the Emissions(in percent) in Tajikistan in 1995 to that in 2008?
Keep it short and to the point. 0.19. What is the ratio of the Emissions(in percent) of Middle income in 1995 to that in 2009?
Provide a short and direct response. 0.94. What is the ratio of the Emissions(in percent) in Azerbaijan in 1995 to that in 2009?
Ensure brevity in your answer.  0.95. What is the ratio of the Emissions(in percent) in Spain in 1995 to that in 2009?
Your answer should be compact. 2.15. What is the ratio of the Emissions(in percent) in Tajikistan in 1995 to that in 2009?
Give a very brief answer. 0.2. What is the ratio of the Emissions(in percent) in Middle income in 1995 to that in 2010?
Provide a succinct answer. 0.94. What is the ratio of the Emissions(in percent) of Azerbaijan in 1995 to that in 2010?
Make the answer very short. 0.61. What is the ratio of the Emissions(in percent) in Spain in 1995 to that in 2010?
Provide a succinct answer. 2.62. What is the ratio of the Emissions(in percent) in Tajikistan in 1995 to that in 2010?
Make the answer very short. 0.19. What is the ratio of the Emissions(in percent) in Middle income in 1996 to that in 1997?
Keep it short and to the point. 1.02. What is the ratio of the Emissions(in percent) of Azerbaijan in 1996 to that in 1997?
Your answer should be very brief. 0.95. What is the ratio of the Emissions(in percent) in Spain in 1996 to that in 1997?
Your answer should be compact. 0.96. What is the ratio of the Emissions(in percent) of Tajikistan in 1996 to that in 1997?
Provide a short and direct response. 0.27. What is the ratio of the Emissions(in percent) in Middle income in 1996 to that in 1998?
Offer a very short reply. 1.05. What is the ratio of the Emissions(in percent) in Azerbaijan in 1996 to that in 1998?
Your response must be concise. 4.02. What is the ratio of the Emissions(in percent) in Spain in 1996 to that in 1998?
Ensure brevity in your answer.  1.03. What is the ratio of the Emissions(in percent) in Tajikistan in 1996 to that in 1998?
Offer a terse response. 0.41. What is the ratio of the Emissions(in percent) of Middle income in 1996 to that in 2007?
Your answer should be compact. 0.95. What is the ratio of the Emissions(in percent) of Azerbaijan in 1996 to that in 2007?
Provide a short and direct response. 0.65. What is the ratio of the Emissions(in percent) in Spain in 1996 to that in 2007?
Keep it short and to the point. 1.26. What is the ratio of the Emissions(in percent) in Tajikistan in 1996 to that in 2007?
Ensure brevity in your answer.  0.08. What is the ratio of the Emissions(in percent) of Middle income in 1996 to that in 2008?
Your answer should be compact. 0.94. What is the ratio of the Emissions(in percent) in Azerbaijan in 1996 to that in 2008?
Provide a short and direct response. 1.13. What is the ratio of the Emissions(in percent) of Spain in 1996 to that in 2008?
Provide a succinct answer. 1.62. What is the ratio of the Emissions(in percent) of Tajikistan in 1996 to that in 2008?
Give a very brief answer. 0.07. What is the ratio of the Emissions(in percent) in Middle income in 1996 to that in 2009?
Provide a succinct answer. 0.93. What is the ratio of the Emissions(in percent) of Azerbaijan in 1996 to that in 2009?
Your answer should be compact. 1.01. What is the ratio of the Emissions(in percent) in Spain in 1996 to that in 2009?
Your answer should be very brief. 1.9. What is the ratio of the Emissions(in percent) of Tajikistan in 1996 to that in 2009?
Make the answer very short. 0.07. What is the ratio of the Emissions(in percent) in Middle income in 1996 to that in 2010?
Make the answer very short. 0.94. What is the ratio of the Emissions(in percent) in Azerbaijan in 1996 to that in 2010?
Provide a short and direct response. 0.65. What is the ratio of the Emissions(in percent) in Spain in 1996 to that in 2010?
Your answer should be compact. 2.31. What is the ratio of the Emissions(in percent) of Tajikistan in 1996 to that in 2010?
Provide a short and direct response. 0.07. What is the ratio of the Emissions(in percent) in Middle income in 1997 to that in 1998?
Ensure brevity in your answer.  1.03. What is the ratio of the Emissions(in percent) of Azerbaijan in 1997 to that in 1998?
Provide a succinct answer. 4.25. What is the ratio of the Emissions(in percent) in Spain in 1997 to that in 1998?
Keep it short and to the point. 1.08. What is the ratio of the Emissions(in percent) in Tajikistan in 1997 to that in 1998?
Offer a very short reply. 1.52. What is the ratio of the Emissions(in percent) of Middle income in 1997 to that in 2007?
Give a very brief answer. 0.93. What is the ratio of the Emissions(in percent) in Azerbaijan in 1997 to that in 2007?
Your response must be concise. 0.68. What is the ratio of the Emissions(in percent) in Spain in 1997 to that in 2007?
Keep it short and to the point. 1.31. What is the ratio of the Emissions(in percent) in Tajikistan in 1997 to that in 2007?
Ensure brevity in your answer.  0.31. What is the ratio of the Emissions(in percent) of Middle income in 1997 to that in 2008?
Offer a terse response. 0.93. What is the ratio of the Emissions(in percent) in Azerbaijan in 1997 to that in 2008?
Your answer should be compact. 1.19. What is the ratio of the Emissions(in percent) of Spain in 1997 to that in 2008?
Your answer should be compact. 1.69. What is the ratio of the Emissions(in percent) of Tajikistan in 1997 to that in 2008?
Keep it short and to the point. 0.26. What is the ratio of the Emissions(in percent) of Middle income in 1997 to that in 2009?
Offer a terse response. 0.92. What is the ratio of the Emissions(in percent) in Azerbaijan in 1997 to that in 2009?
Make the answer very short. 1.07. What is the ratio of the Emissions(in percent) in Spain in 1997 to that in 2009?
Provide a succinct answer. 1.99. What is the ratio of the Emissions(in percent) in Tajikistan in 1997 to that in 2009?
Ensure brevity in your answer.  0.28. What is the ratio of the Emissions(in percent) of Middle income in 1997 to that in 2010?
Provide a succinct answer. 0.92. What is the ratio of the Emissions(in percent) of Azerbaijan in 1997 to that in 2010?
Offer a terse response. 0.69. What is the ratio of the Emissions(in percent) in Spain in 1997 to that in 2010?
Your answer should be compact. 2.41. What is the ratio of the Emissions(in percent) in Tajikistan in 1997 to that in 2010?
Make the answer very short. 0.26. What is the ratio of the Emissions(in percent) in Middle income in 1998 to that in 2007?
Give a very brief answer. 0.9. What is the ratio of the Emissions(in percent) of Azerbaijan in 1998 to that in 2007?
Your answer should be very brief. 0.16. What is the ratio of the Emissions(in percent) of Spain in 1998 to that in 2007?
Ensure brevity in your answer.  1.22. What is the ratio of the Emissions(in percent) in Tajikistan in 1998 to that in 2007?
Keep it short and to the point. 0.21. What is the ratio of the Emissions(in percent) in Middle income in 1998 to that in 2008?
Offer a very short reply. 0.9. What is the ratio of the Emissions(in percent) in Azerbaijan in 1998 to that in 2008?
Give a very brief answer. 0.28. What is the ratio of the Emissions(in percent) in Spain in 1998 to that in 2008?
Give a very brief answer. 1.57. What is the ratio of the Emissions(in percent) in Tajikistan in 1998 to that in 2008?
Make the answer very short. 0.17. What is the ratio of the Emissions(in percent) in Middle income in 1998 to that in 2009?
Your answer should be very brief. 0.89. What is the ratio of the Emissions(in percent) of Azerbaijan in 1998 to that in 2009?
Your answer should be compact. 0.25. What is the ratio of the Emissions(in percent) of Spain in 1998 to that in 2009?
Your answer should be very brief. 1.84. What is the ratio of the Emissions(in percent) in Tajikistan in 1998 to that in 2009?
Keep it short and to the point. 0.18. What is the ratio of the Emissions(in percent) in Middle income in 1998 to that in 2010?
Ensure brevity in your answer.  0.9. What is the ratio of the Emissions(in percent) of Azerbaijan in 1998 to that in 2010?
Your answer should be compact. 0.16. What is the ratio of the Emissions(in percent) of Spain in 1998 to that in 2010?
Your answer should be very brief. 2.24. What is the ratio of the Emissions(in percent) in Tajikistan in 1998 to that in 2010?
Give a very brief answer. 0.17. What is the ratio of the Emissions(in percent) of Azerbaijan in 2007 to that in 2008?
Keep it short and to the point. 1.75. What is the ratio of the Emissions(in percent) in Spain in 2007 to that in 2008?
Ensure brevity in your answer.  1.29. What is the ratio of the Emissions(in percent) of Tajikistan in 2007 to that in 2008?
Ensure brevity in your answer.  0.83. What is the ratio of the Emissions(in percent) of Middle income in 2007 to that in 2009?
Offer a terse response. 0.98. What is the ratio of the Emissions(in percent) in Azerbaijan in 2007 to that in 2009?
Give a very brief answer. 1.57. What is the ratio of the Emissions(in percent) of Spain in 2007 to that in 2009?
Provide a succinct answer. 1.51. What is the ratio of the Emissions(in percent) in Tajikistan in 2007 to that in 2009?
Give a very brief answer. 0.88. What is the ratio of the Emissions(in percent) of Middle income in 2007 to that in 2010?
Keep it short and to the point. 0.99. What is the ratio of the Emissions(in percent) of Spain in 2007 to that in 2010?
Your response must be concise. 1.84. What is the ratio of the Emissions(in percent) in Tajikistan in 2007 to that in 2010?
Provide a short and direct response. 0.82. What is the ratio of the Emissions(in percent) of Middle income in 2008 to that in 2009?
Keep it short and to the point. 0.99. What is the ratio of the Emissions(in percent) in Azerbaijan in 2008 to that in 2009?
Provide a succinct answer. 0.9. What is the ratio of the Emissions(in percent) of Spain in 2008 to that in 2009?
Your answer should be compact. 1.17. What is the ratio of the Emissions(in percent) of Tajikistan in 2008 to that in 2009?
Offer a very short reply. 1.06. What is the ratio of the Emissions(in percent) in Azerbaijan in 2008 to that in 2010?
Give a very brief answer. 0.58. What is the ratio of the Emissions(in percent) of Spain in 2008 to that in 2010?
Give a very brief answer. 1.43. What is the ratio of the Emissions(in percent) of Tajikistan in 2008 to that in 2010?
Your response must be concise. 0.99. What is the ratio of the Emissions(in percent) of Azerbaijan in 2009 to that in 2010?
Offer a very short reply. 0.64. What is the ratio of the Emissions(in percent) of Spain in 2009 to that in 2010?
Provide a succinct answer. 1.22. What is the ratio of the Emissions(in percent) of Tajikistan in 2009 to that in 2010?
Your answer should be very brief. 0.93. What is the difference between the highest and the second highest Emissions(in percent) of Middle income?
Your response must be concise. 0.32. What is the difference between the highest and the second highest Emissions(in percent) of Azerbaijan?
Ensure brevity in your answer.  0. What is the difference between the highest and the second highest Emissions(in percent) in Spain?
Provide a short and direct response. 2.35. What is the difference between the highest and the second highest Emissions(in percent) in Tajikistan?
Offer a very short reply. 0.14. What is the difference between the highest and the lowest Emissions(in percent) of Middle income?
Offer a terse response. 5.95. What is the difference between the highest and the lowest Emissions(in percent) in Azerbaijan?
Make the answer very short. 0.06. What is the difference between the highest and the lowest Emissions(in percent) of Spain?
Offer a terse response. 18.53. What is the difference between the highest and the lowest Emissions(in percent) of Tajikistan?
Your response must be concise. 10.48. 